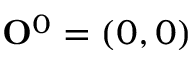<formula> <loc_0><loc_0><loc_500><loc_500>{ O } ^ { 0 } = ( 0 , 0 )</formula> 